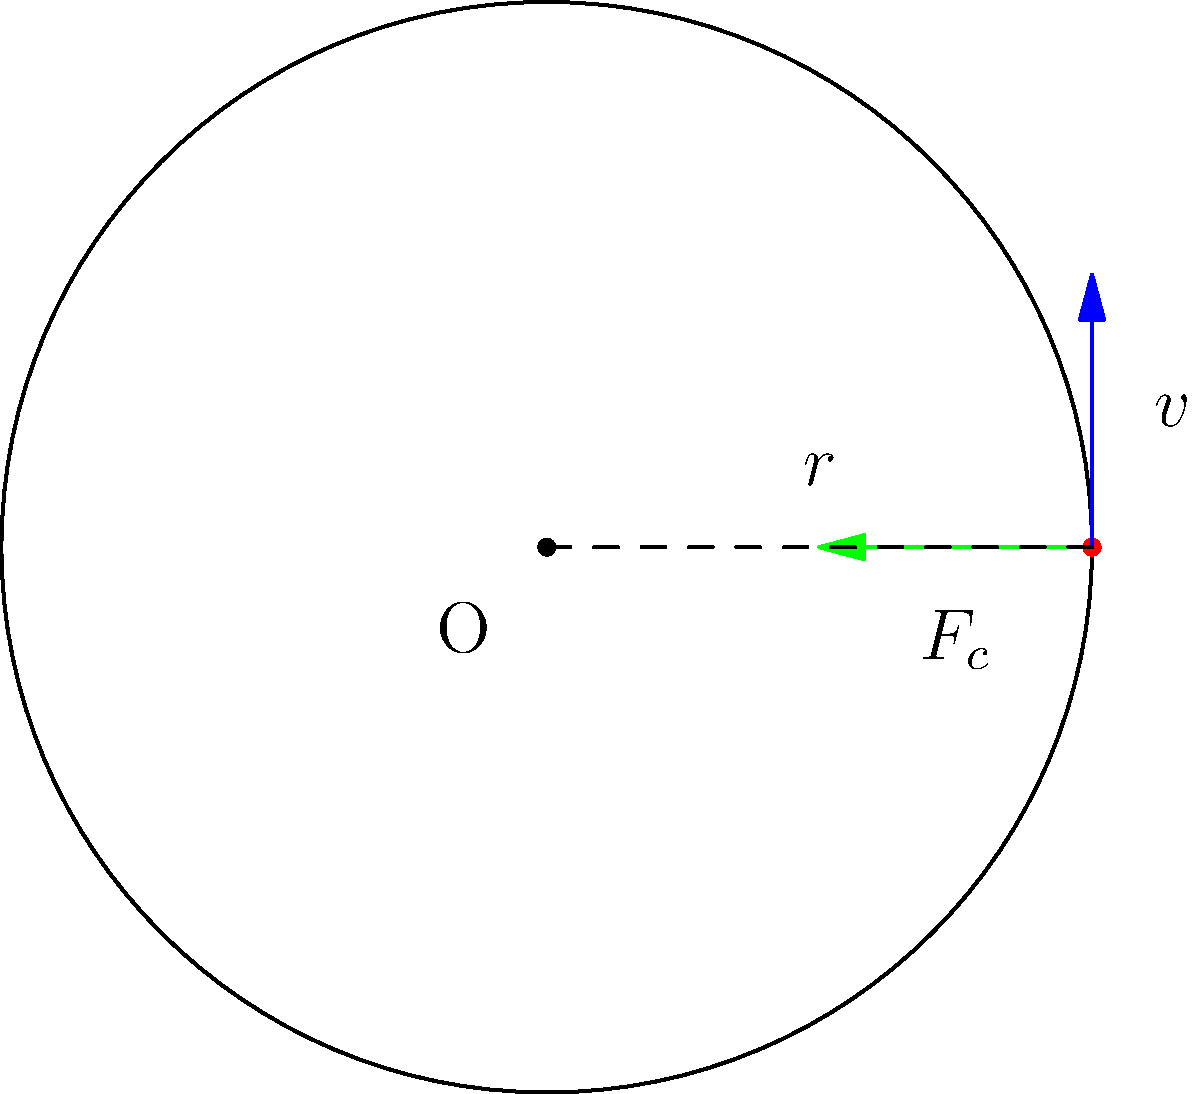An ancient Persian wheel, similar to a modern Ferris wheel, has a radius of 5 meters and completes one revolution every 12 seconds. If a 70 kg rider is at the outer edge of the wheel, what is the magnitude of the centripetal force acting on the rider? Let's approach this step-by-step:

1) First, we need to calculate the angular velocity $\omega$:
   One revolution takes 12 seconds, so:
   $\omega = \frac{2\pi}{T} = \frac{2\pi}{12} = \frac{\pi}{6}$ rad/s

2) Now, we can calculate the linear velocity $v$ of the rider:
   $v = r\omega = 5 \cdot \frac{\pi}{6} = \frac{5\pi}{6}$ m/s

3) The formula for centripetal force is:
   $F_c = m\frac{v^2}{r}$

4) We have:
   $m = 70$ kg
   $v = \frac{5\pi}{6}$ m/s
   $r = 5$ m

5) Let's substitute these values:
   $F_c = 70 \cdot \frac{(\frac{5\pi}{6})^2}{5}$

6) Simplify:
   $F_c = 70 \cdot \frac{25\pi^2}{36 \cdot 5} = \frac{1750\pi^2}{180} \approx 95.8$ N

Therefore, the magnitude of the centripetal force acting on the rider is approximately 95.8 N.
Answer: 95.8 N 